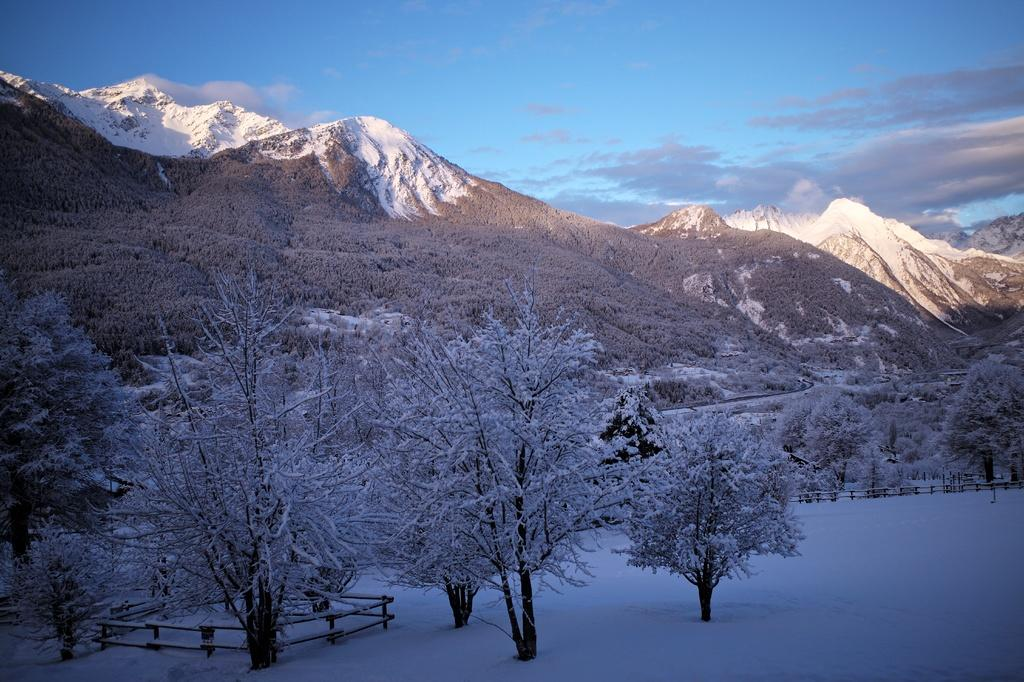What type of vegetation is present in the image? There are many trees in the image. What type of structure can be seen in the image? Railings are visible in the image. What is the weather like in the image? There is snow in the image, indicating cold weather. What type of geographical feature is present in the image? Mountains are present in the image. How many beads are hanging from the trees in the image? There are no beads present in the image; it features trees, railings, snow, and mountains. What type of cakes are being served on the mountains in the image? There are no cakes present in the image; it features trees, railings, snow, and mountains. 